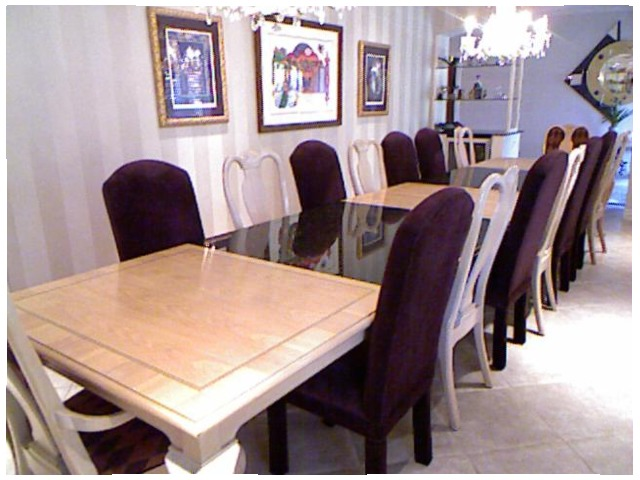<image>
Is the chair on the table? No. The chair is not positioned on the table. They may be near each other, but the chair is not supported by or resting on top of the table. Where is the chair in relation to the chair? Is it behind the chair? No. The chair is not behind the chair. From this viewpoint, the chair appears to be positioned elsewhere in the scene. Where is the chair in relation to the table? Is it under the table? Yes. The chair is positioned underneath the table, with the table above it in the vertical space. 